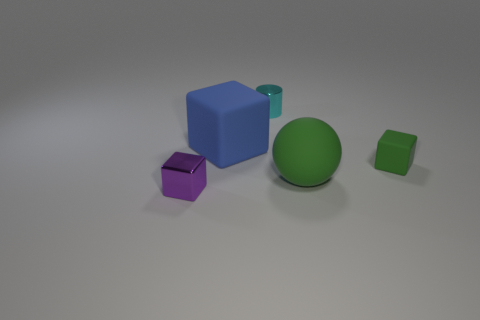Is the shape of the small green matte object the same as the large blue rubber thing?
Offer a very short reply. Yes. How many other things are there of the same size as the metal cylinder?
Offer a very short reply. 2. Are there any tiny shiny things behind the matte ball?
Your answer should be compact. Yes. There is a matte sphere; is it the same color as the small block that is on the right side of the metallic cylinder?
Provide a succinct answer. Yes. What color is the large object that is behind the rubber thing in front of the tiny cube on the right side of the small purple shiny cube?
Offer a very short reply. Blue. Is there a tiny purple metal object of the same shape as the cyan object?
Your answer should be very brief. No. There is a cylinder that is the same size as the purple metal thing; what color is it?
Your answer should be compact. Cyan. What material is the tiny object on the left side of the small cyan metal object?
Give a very brief answer. Metal. There is a large rubber thing behind the big green thing; is it the same shape as the large matte thing that is in front of the blue rubber cube?
Offer a very short reply. No. Is the number of big green objects that are to the left of the large sphere the same as the number of matte spheres?
Provide a short and direct response. No. 